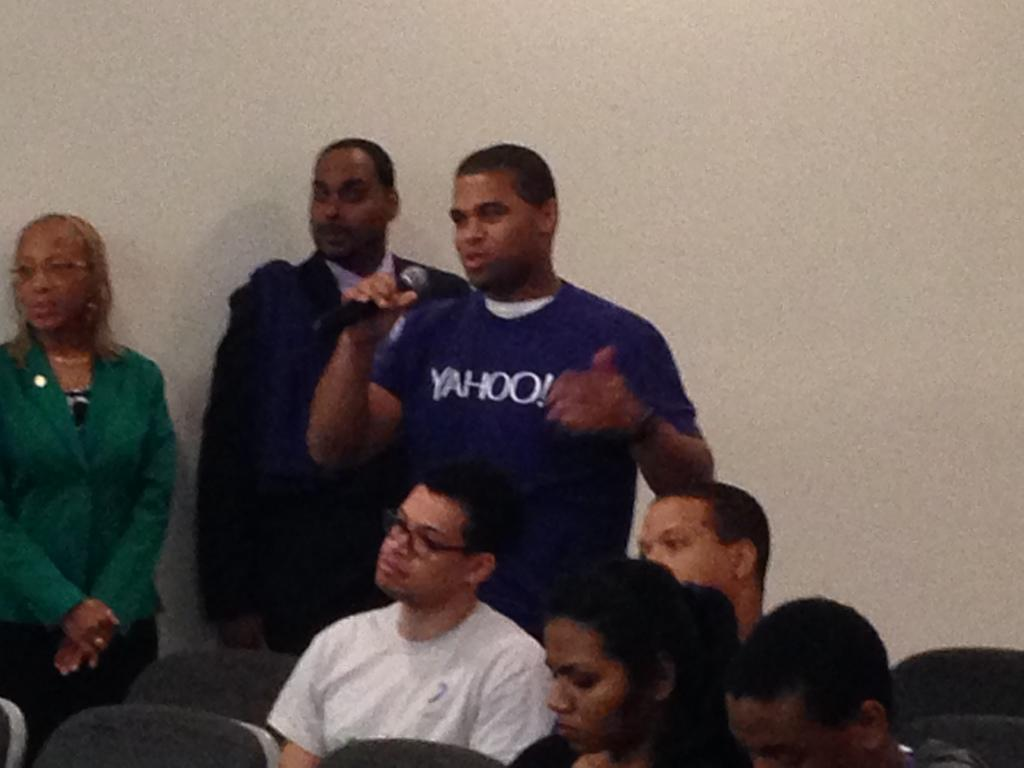How many people are in the image? There are people in the image, but the exact number is not specified. What is one person doing in the image? One person is holding a microphone. What type of furniture is present in the image? There are chairs in the image. What type of structure is visible in the image? There is a wall visible in the image. How much income does the person holding the microphone earn in the image? There is no information about income in the image. 